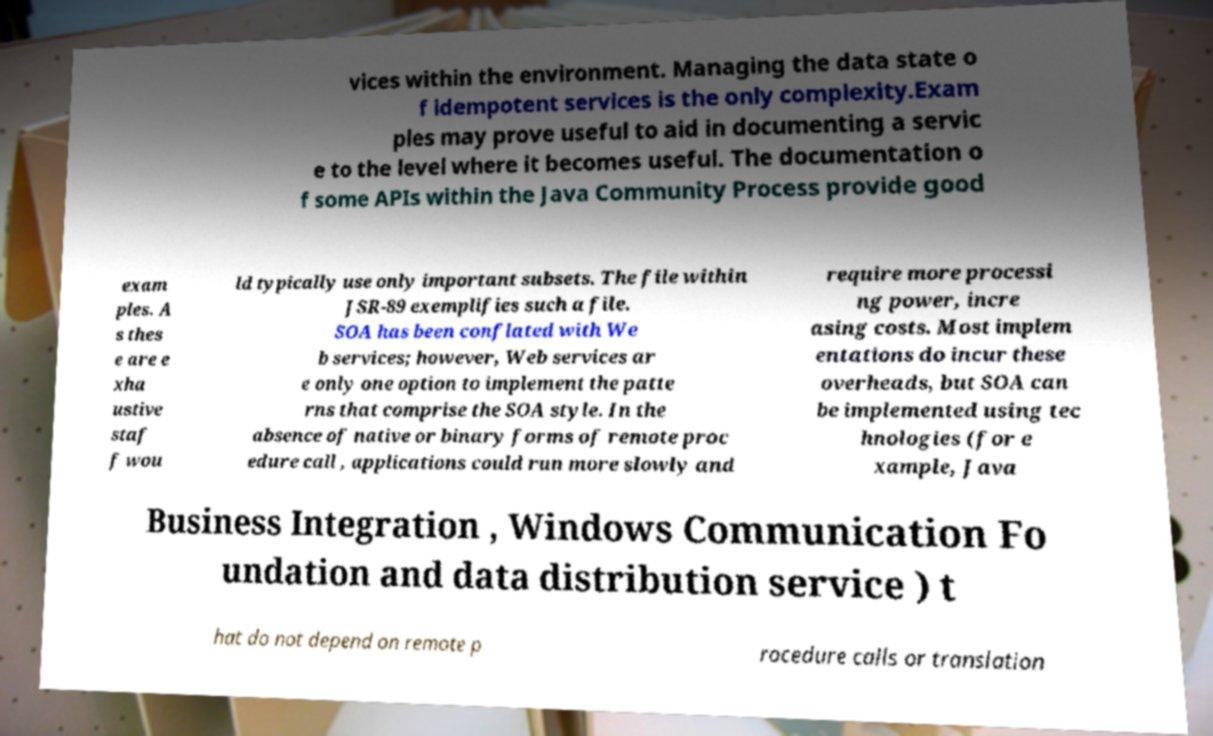I need the written content from this picture converted into text. Can you do that? vices within the environment. Managing the data state o f idempotent services is the only complexity.Exam ples may prove useful to aid in documenting a servic e to the level where it becomes useful. The documentation o f some APIs within the Java Community Process provide good exam ples. A s thes e are e xha ustive staf f wou ld typically use only important subsets. The file within JSR-89 exemplifies such a file. SOA has been conflated with We b services; however, Web services ar e only one option to implement the patte rns that comprise the SOA style. In the absence of native or binary forms of remote proc edure call , applications could run more slowly and require more processi ng power, incre asing costs. Most implem entations do incur these overheads, but SOA can be implemented using tec hnologies (for e xample, Java Business Integration , Windows Communication Fo undation and data distribution service ) t hat do not depend on remote p rocedure calls or translation 